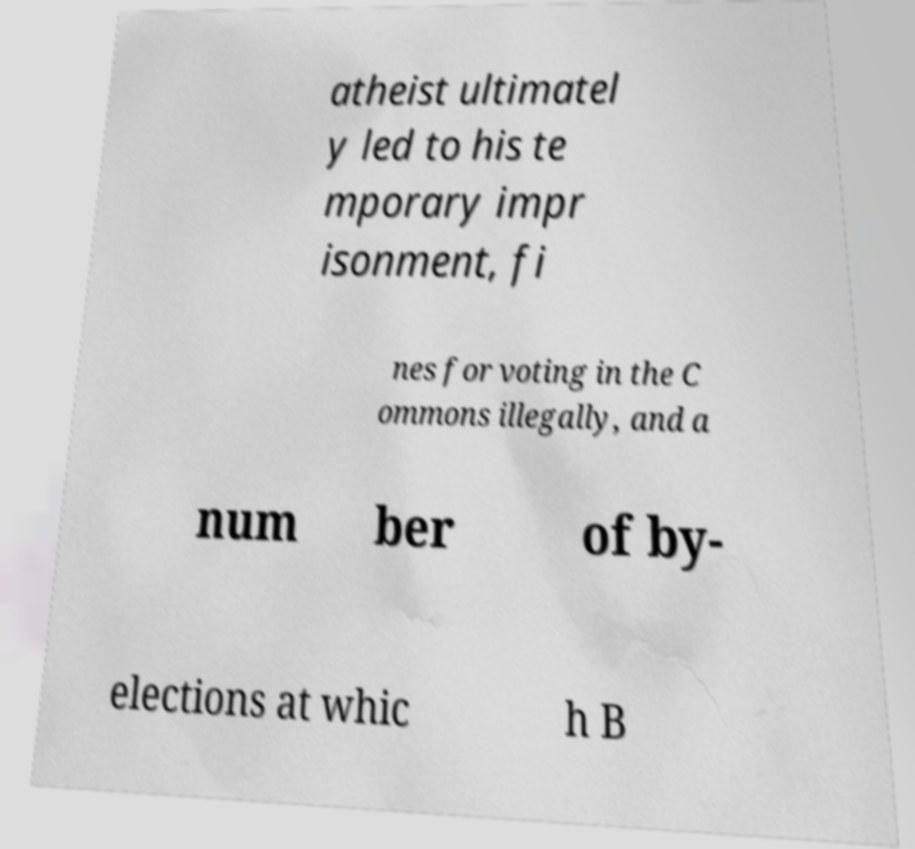Can you accurately transcribe the text from the provided image for me? atheist ultimatel y led to his te mporary impr isonment, fi nes for voting in the C ommons illegally, and a num ber of by- elections at whic h B 